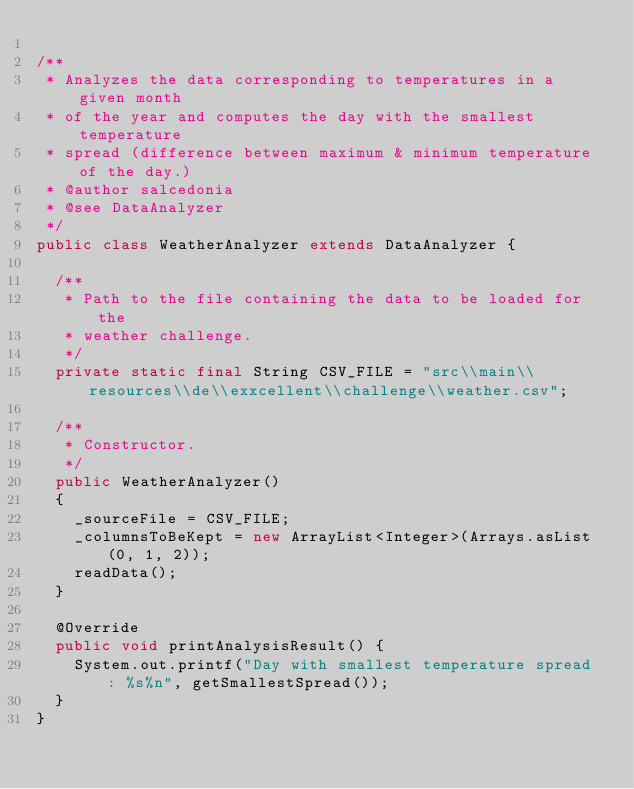<code> <loc_0><loc_0><loc_500><loc_500><_Java_>
/**
 * Analyzes the data corresponding to temperatures in a given month
 * of the year and computes the day with the smallest temperature 
 * spread (difference between maximum & minimum temperature of the day.)  
 * @author salcedonia
 * @see DataAnalyzer
 */
public class WeatherAnalyzer extends DataAnalyzer {
	
	/**
	 * Path to the file containing the data to be loaded for the
	 * weather challenge.
	 */
	private static final String CSV_FILE = "src\\main\\resources\\de\\exxcellent\\challenge\\weather.csv";
	
	/**
	 * Constructor.
	 */
	public WeatherAnalyzer()
	{
		_sourceFile = CSV_FILE;
		_columnsToBeKept = new ArrayList<Integer>(Arrays.asList(0, 1, 2));
		readData();
	}

	@Override
	public void printAnalysisResult() {
		System.out.printf("Day with smallest temperature spread : %s%n", getSmallestSpread());
	}
}
</code> 